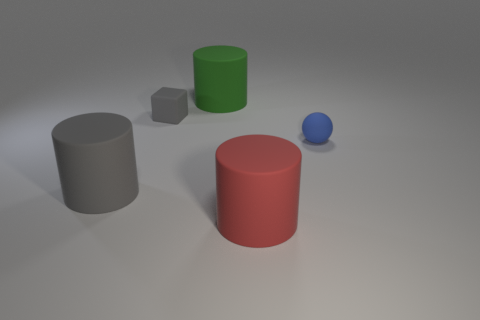Add 2 cylinders. How many objects exist? 7 Subtract all cylinders. How many objects are left? 2 Add 3 large gray objects. How many large gray objects are left? 4 Add 3 small blue rubber things. How many small blue rubber things exist? 4 Subtract 0 brown cubes. How many objects are left? 5 Subtract all matte cubes. Subtract all green rubber things. How many objects are left? 3 